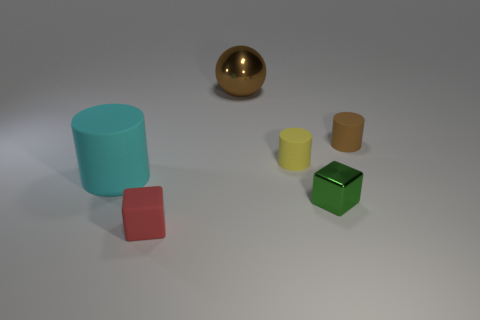Add 1 green metal blocks. How many objects exist? 7 Subtract all cubes. How many objects are left? 4 Subtract all tiny matte objects. Subtract all matte cubes. How many objects are left? 2 Add 2 brown matte cylinders. How many brown matte cylinders are left? 3 Add 3 green metal blocks. How many green metal blocks exist? 4 Subtract 1 yellow cylinders. How many objects are left? 5 